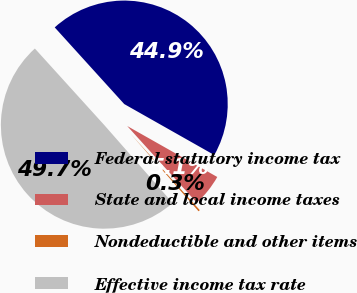Convert chart to OTSL. <chart><loc_0><loc_0><loc_500><loc_500><pie_chart><fcel>Federal statutory income tax<fcel>State and local income taxes<fcel>Nondeductible and other items<fcel>Effective income tax rate<nl><fcel>44.92%<fcel>5.08%<fcel>0.26%<fcel>49.74%<nl></chart> 